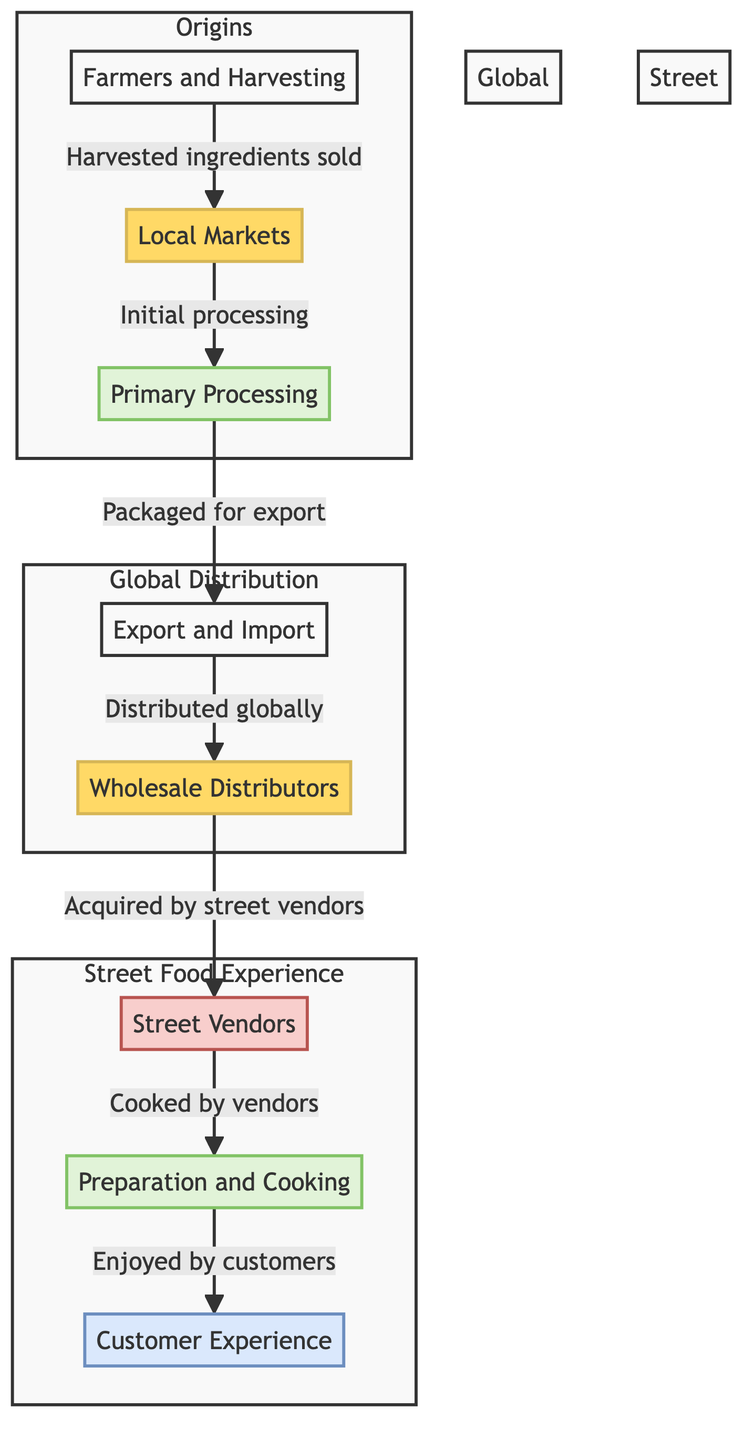What are the three main stages depicted in the diagram? The diagram is divided into three main stages: Origins, Global Distribution, and Street Food Experience. Each stage groups related nodes, showing the flow of ingredients from their source to the customer.
Answer: Origins, Global Distribution, Street Food Experience How many nodes represent the final customer experience in the diagram? The final customer experience is represented by the node "Customer Experience", which is the last node in the "Street Food Experience" subgraph. There is only one node representing this experience.
Answer: 1 Which node represents the primary processing of ingredients? The node labeled "Primary Processing" is identified by the number 3 in the diagram, indicating the initial processing step after distribution from local markets.
Answer: Primary Processing What is the flow direction from street vendors to the customer experience? The flow direction is one-way, from the "Street Vendors" node to the "Customer Experience" node, indicating that the process involves vendors preparing food for customers.
Answer: One-way How many edges are depicted in the diagram? By counting the directional arrows connecting the nodes, there are a total of 7 edges in the diagram, illustrating the movement of ingredients through the entire supply chain.
Answer: 7 Which node follows "Wholesale Distributors" in the diagram? The node that follows "Wholesale Distributors" is "Street Vendors", indicating that vendors acquire ingredients from distributors as the next step in the chain.
Answer: Street Vendors What stage encompasses the nodes for cooking and customer enjoyment? The stage that encompasses "Preparation and Cooking" and "Customer Experience" nodes is labeled as "Street Food Experience", highlighting the final steps in the supply chain.
Answer: Street Food Experience What type of market do street vendors acquire their ingredients from? Street vendors acquire their ingredients from "Wholesale Distributors," which serve as intermediaries in the supply chain, providing ingredients that have been processed and packaged.
Answer: Wholesale Distributors 